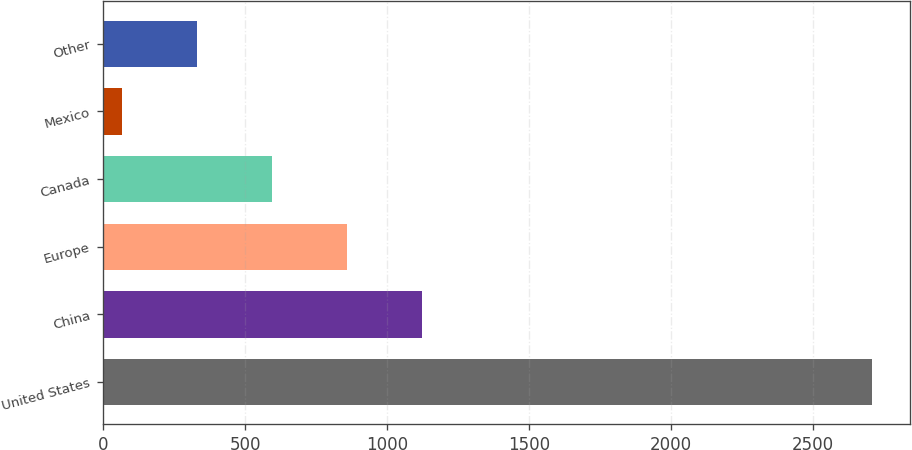Convert chart. <chart><loc_0><loc_0><loc_500><loc_500><bar_chart><fcel>United States<fcel>China<fcel>Europe<fcel>Canada<fcel>Mexico<fcel>Other<nl><fcel>2705.9<fcel>1121.06<fcel>856.92<fcel>592.78<fcel>64.5<fcel>328.64<nl></chart> 